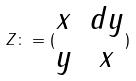<formula> <loc_0><loc_0><loc_500><loc_500>Z \colon = ( \begin{matrix} x & d y \\ y & x \end{matrix} )</formula> 